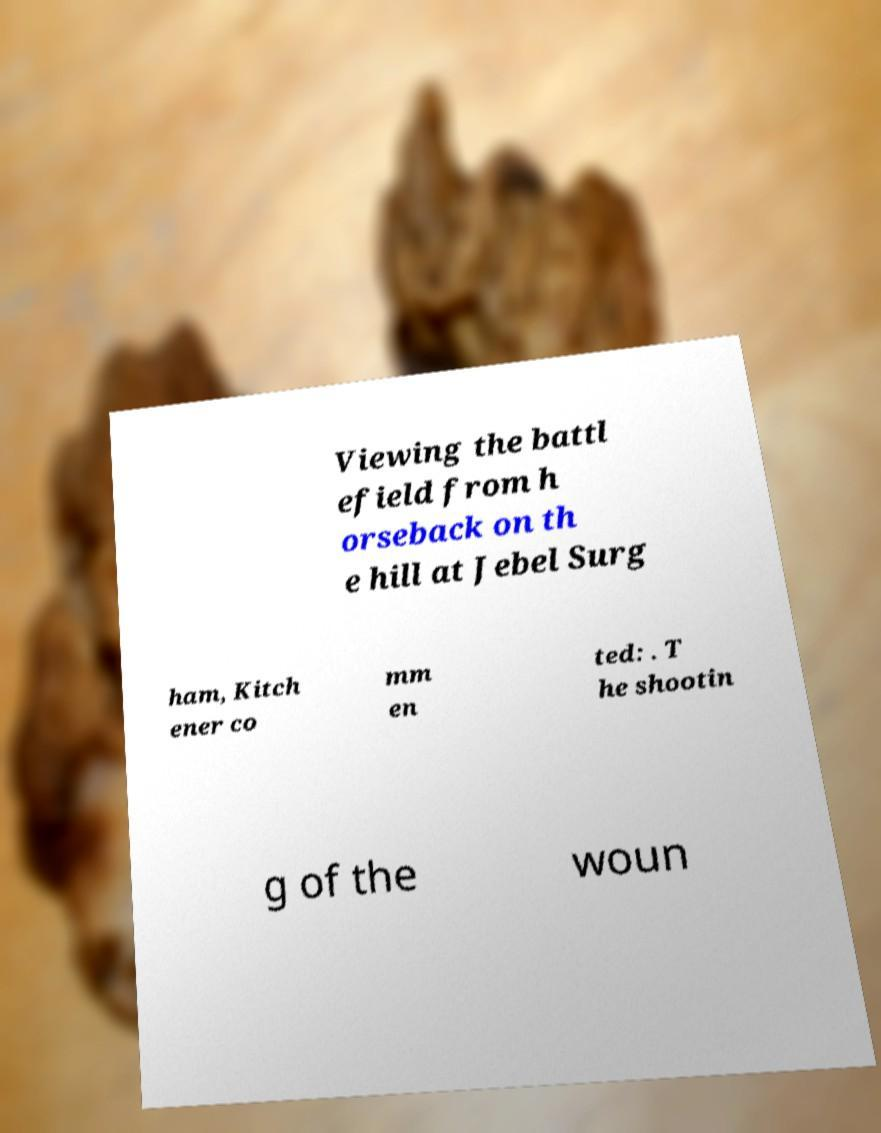What messages or text are displayed in this image? I need them in a readable, typed format. Viewing the battl efield from h orseback on th e hill at Jebel Surg ham, Kitch ener co mm en ted: . T he shootin g of the woun 